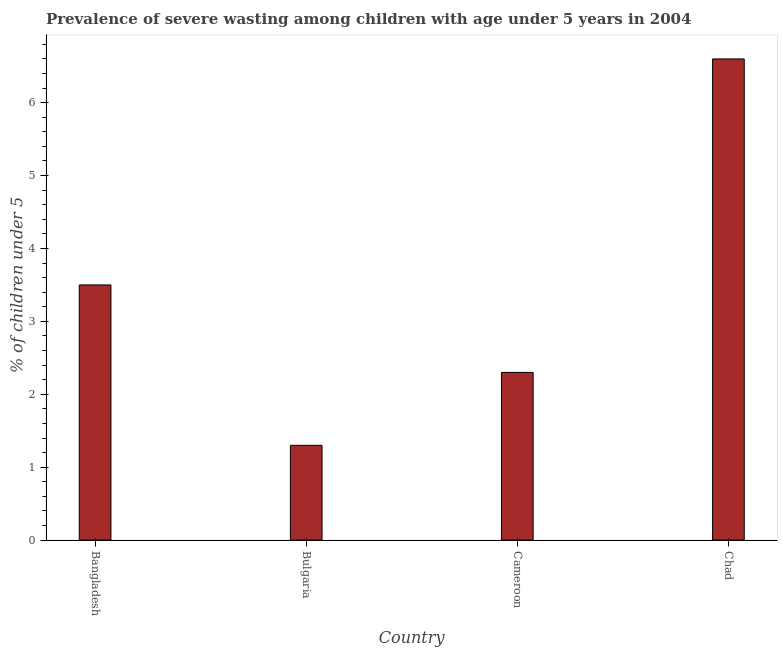Does the graph contain any zero values?
Provide a succinct answer. No. Does the graph contain grids?
Provide a succinct answer. No. What is the title of the graph?
Your response must be concise. Prevalence of severe wasting among children with age under 5 years in 2004. What is the label or title of the X-axis?
Give a very brief answer. Country. What is the label or title of the Y-axis?
Your response must be concise.  % of children under 5. What is the prevalence of severe wasting in Cameroon?
Your response must be concise. 2.3. Across all countries, what is the maximum prevalence of severe wasting?
Ensure brevity in your answer.  6.6. Across all countries, what is the minimum prevalence of severe wasting?
Your response must be concise. 1.3. In which country was the prevalence of severe wasting maximum?
Ensure brevity in your answer.  Chad. In which country was the prevalence of severe wasting minimum?
Your answer should be very brief. Bulgaria. What is the sum of the prevalence of severe wasting?
Offer a very short reply. 13.7. What is the average prevalence of severe wasting per country?
Provide a short and direct response. 3.42. What is the median prevalence of severe wasting?
Ensure brevity in your answer.  2.9. What is the ratio of the prevalence of severe wasting in Bulgaria to that in Cameroon?
Your answer should be compact. 0.56. What is the difference between the highest and the second highest prevalence of severe wasting?
Your answer should be very brief. 3.1. In how many countries, is the prevalence of severe wasting greater than the average prevalence of severe wasting taken over all countries?
Ensure brevity in your answer.  2. How many bars are there?
Make the answer very short. 4. Are the values on the major ticks of Y-axis written in scientific E-notation?
Give a very brief answer. No. What is the  % of children under 5 of Bangladesh?
Your answer should be very brief. 3.5. What is the  % of children under 5 of Bulgaria?
Offer a terse response. 1.3. What is the  % of children under 5 in Cameroon?
Your answer should be very brief. 2.3. What is the  % of children under 5 in Chad?
Make the answer very short. 6.6. What is the difference between the  % of children under 5 in Bangladesh and Cameroon?
Give a very brief answer. 1.2. What is the difference between the  % of children under 5 in Bulgaria and Chad?
Your answer should be compact. -5.3. What is the difference between the  % of children under 5 in Cameroon and Chad?
Offer a very short reply. -4.3. What is the ratio of the  % of children under 5 in Bangladesh to that in Bulgaria?
Your response must be concise. 2.69. What is the ratio of the  % of children under 5 in Bangladesh to that in Cameroon?
Offer a terse response. 1.52. What is the ratio of the  % of children under 5 in Bangladesh to that in Chad?
Ensure brevity in your answer.  0.53. What is the ratio of the  % of children under 5 in Bulgaria to that in Cameroon?
Give a very brief answer. 0.56. What is the ratio of the  % of children under 5 in Bulgaria to that in Chad?
Give a very brief answer. 0.2. What is the ratio of the  % of children under 5 in Cameroon to that in Chad?
Make the answer very short. 0.35. 